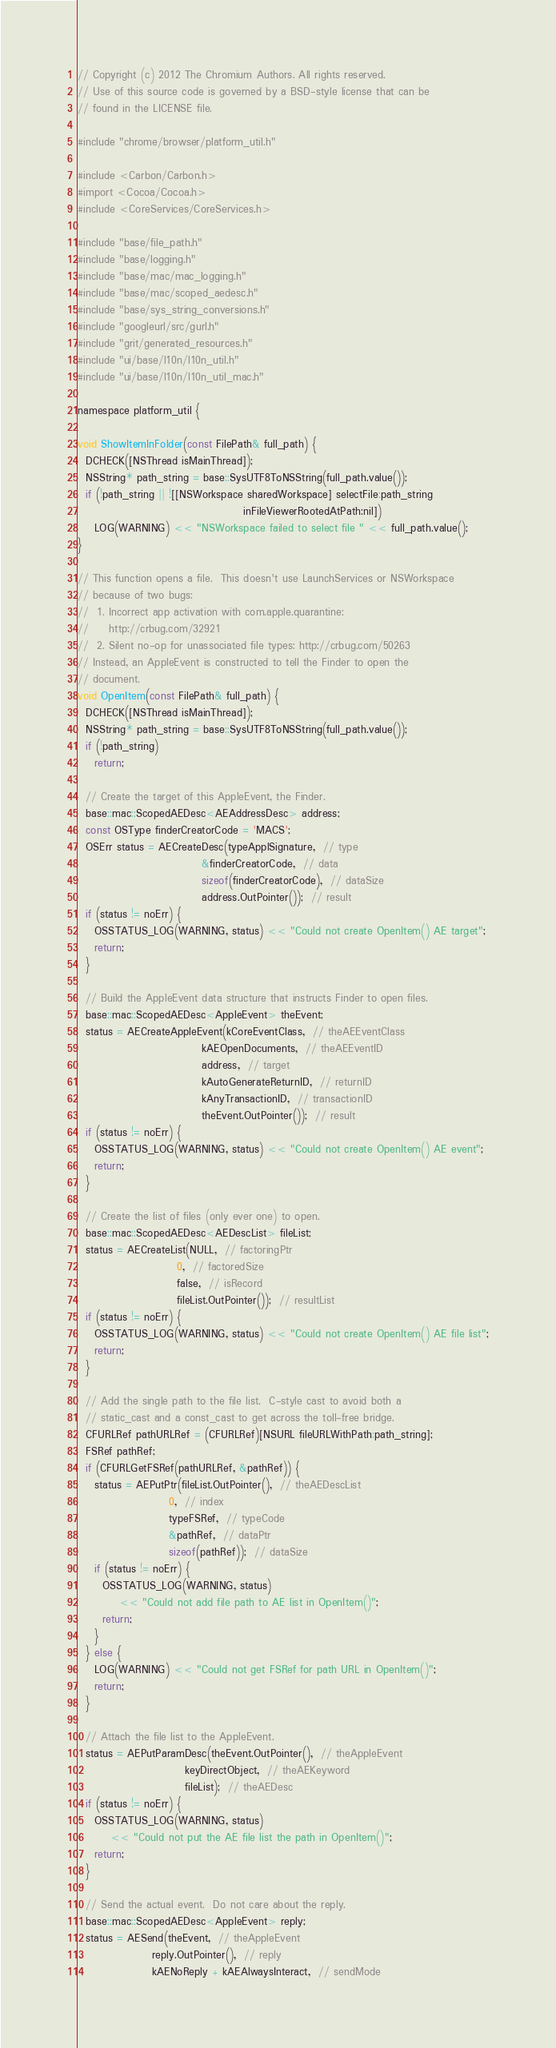Convert code to text. <code><loc_0><loc_0><loc_500><loc_500><_ObjectiveC_>// Copyright (c) 2012 The Chromium Authors. All rights reserved.
// Use of this source code is governed by a BSD-style license that can be
// found in the LICENSE file.

#include "chrome/browser/platform_util.h"

#include <Carbon/Carbon.h>
#import <Cocoa/Cocoa.h>
#include <CoreServices/CoreServices.h>

#include "base/file_path.h"
#include "base/logging.h"
#include "base/mac/mac_logging.h"
#include "base/mac/scoped_aedesc.h"
#include "base/sys_string_conversions.h"
#include "googleurl/src/gurl.h"
#include "grit/generated_resources.h"
#include "ui/base/l10n/l10n_util.h"
#include "ui/base/l10n/l10n_util_mac.h"

namespace platform_util {

void ShowItemInFolder(const FilePath& full_path) {
  DCHECK([NSThread isMainThread]);
  NSString* path_string = base::SysUTF8ToNSString(full_path.value());
  if (!path_string || ![[NSWorkspace sharedWorkspace] selectFile:path_string
                                        inFileViewerRootedAtPath:nil])
    LOG(WARNING) << "NSWorkspace failed to select file " << full_path.value();
}

// This function opens a file.  This doesn't use LaunchServices or NSWorkspace
// because of two bugs:
//  1. Incorrect app activation with com.apple.quarantine:
//     http://crbug.com/32921
//  2. Silent no-op for unassociated file types: http://crbug.com/50263
// Instead, an AppleEvent is constructed to tell the Finder to open the
// document.
void OpenItem(const FilePath& full_path) {
  DCHECK([NSThread isMainThread]);
  NSString* path_string = base::SysUTF8ToNSString(full_path.value());
  if (!path_string)
    return;

  // Create the target of this AppleEvent, the Finder.
  base::mac::ScopedAEDesc<AEAddressDesc> address;
  const OSType finderCreatorCode = 'MACS';
  OSErr status = AECreateDesc(typeApplSignature,  // type
                              &finderCreatorCode,  // data
                              sizeof(finderCreatorCode),  // dataSize
                              address.OutPointer());  // result
  if (status != noErr) {
    OSSTATUS_LOG(WARNING, status) << "Could not create OpenItem() AE target";
    return;
  }

  // Build the AppleEvent data structure that instructs Finder to open files.
  base::mac::ScopedAEDesc<AppleEvent> theEvent;
  status = AECreateAppleEvent(kCoreEventClass,  // theAEEventClass
                              kAEOpenDocuments,  // theAEEventID
                              address,  // target
                              kAutoGenerateReturnID,  // returnID
                              kAnyTransactionID,  // transactionID
                              theEvent.OutPointer());  // result
  if (status != noErr) {
    OSSTATUS_LOG(WARNING, status) << "Could not create OpenItem() AE event";
    return;
  }

  // Create the list of files (only ever one) to open.
  base::mac::ScopedAEDesc<AEDescList> fileList;
  status = AECreateList(NULL,  // factoringPtr
                        0,  // factoredSize
                        false,  // isRecord
                        fileList.OutPointer());  // resultList
  if (status != noErr) {
    OSSTATUS_LOG(WARNING, status) << "Could not create OpenItem() AE file list";
    return;
  }

  // Add the single path to the file list.  C-style cast to avoid both a
  // static_cast and a const_cast to get across the toll-free bridge.
  CFURLRef pathURLRef = (CFURLRef)[NSURL fileURLWithPath:path_string];
  FSRef pathRef;
  if (CFURLGetFSRef(pathURLRef, &pathRef)) {
    status = AEPutPtr(fileList.OutPointer(),  // theAEDescList
                      0,  // index
                      typeFSRef,  // typeCode
                      &pathRef,  // dataPtr
                      sizeof(pathRef));  // dataSize
    if (status != noErr) {
      OSSTATUS_LOG(WARNING, status)
          << "Could not add file path to AE list in OpenItem()";
      return;
    }
  } else {
    LOG(WARNING) << "Could not get FSRef for path URL in OpenItem()";
    return;
  }

  // Attach the file list to the AppleEvent.
  status = AEPutParamDesc(theEvent.OutPointer(),  // theAppleEvent
                          keyDirectObject,  // theAEKeyword
                          fileList);  // theAEDesc
  if (status != noErr) {
    OSSTATUS_LOG(WARNING, status)
        << "Could not put the AE file list the path in OpenItem()";
    return;
  }

  // Send the actual event.  Do not care about the reply.
  base::mac::ScopedAEDesc<AppleEvent> reply;
  status = AESend(theEvent,  // theAppleEvent
                  reply.OutPointer(),  // reply
                  kAENoReply + kAEAlwaysInteract,  // sendMode</code> 